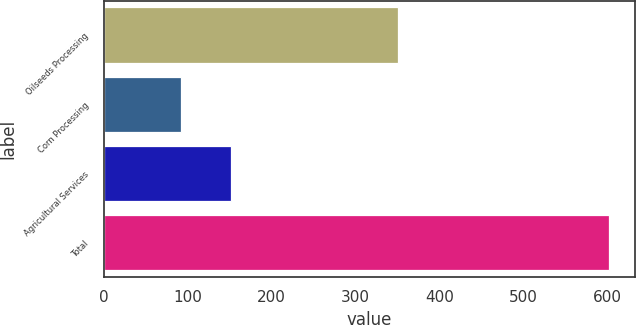<chart> <loc_0><loc_0><loc_500><loc_500><bar_chart><fcel>Oilseeds Processing<fcel>Corn Processing<fcel>Agricultural Services<fcel>Total<nl><fcel>351<fcel>92<fcel>152<fcel>603<nl></chart> 